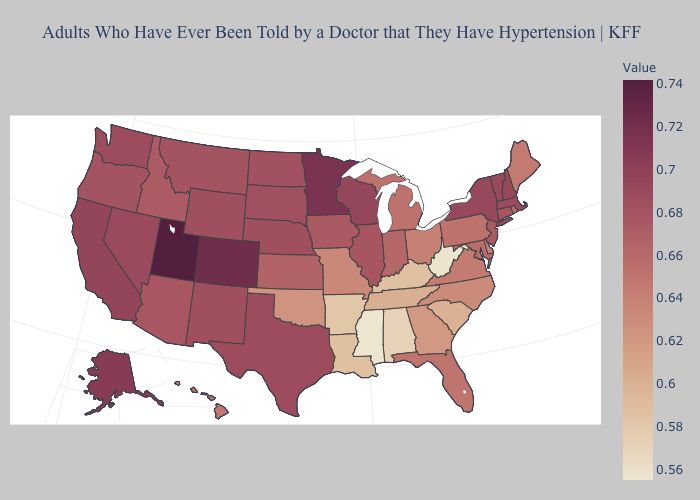Which states have the highest value in the USA?
Quick response, please. Utah. Is the legend a continuous bar?
Keep it brief. Yes. Among the states that border West Virginia , does Pennsylvania have the lowest value?
Concise answer only. No. Among the states that border Virginia , which have the highest value?
Short answer required. Maryland. Which states have the lowest value in the MidWest?
Short answer required. Missouri. Among the states that border North Carolina , which have the highest value?
Short answer required. Virginia. 